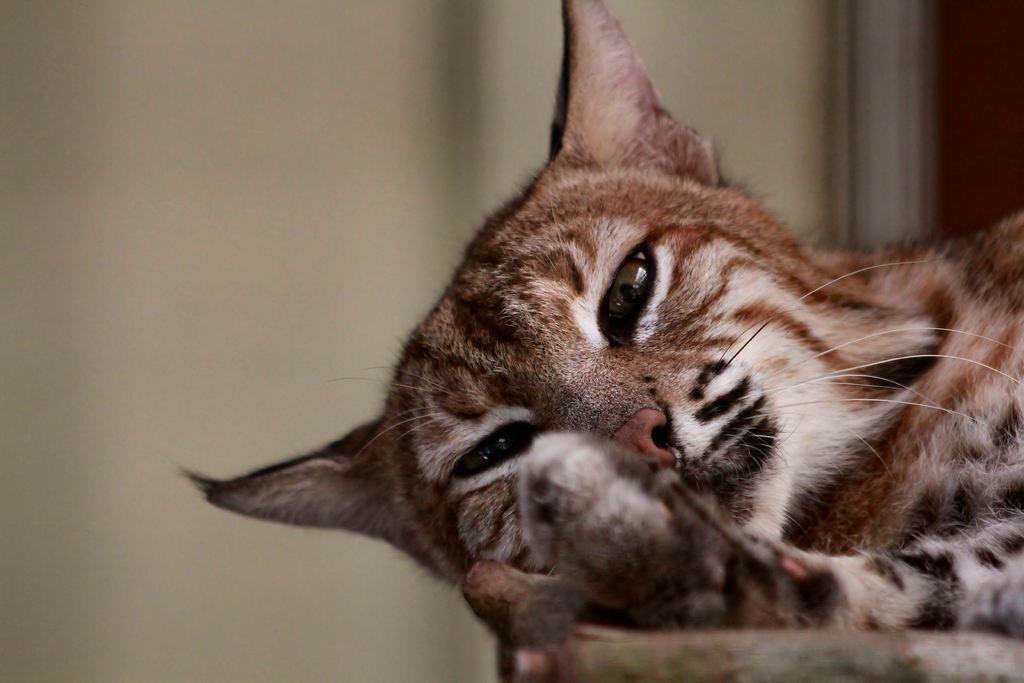Can you describe this image briefly? In this image there is a truncated cat on the surface, there is a white wall behind the wall. 